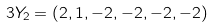<formula> <loc_0><loc_0><loc_500><loc_500>3 Y _ { 2 } = \left ( 2 , 1 , - 2 , - 2 , - 2 , - 2 \right )</formula> 